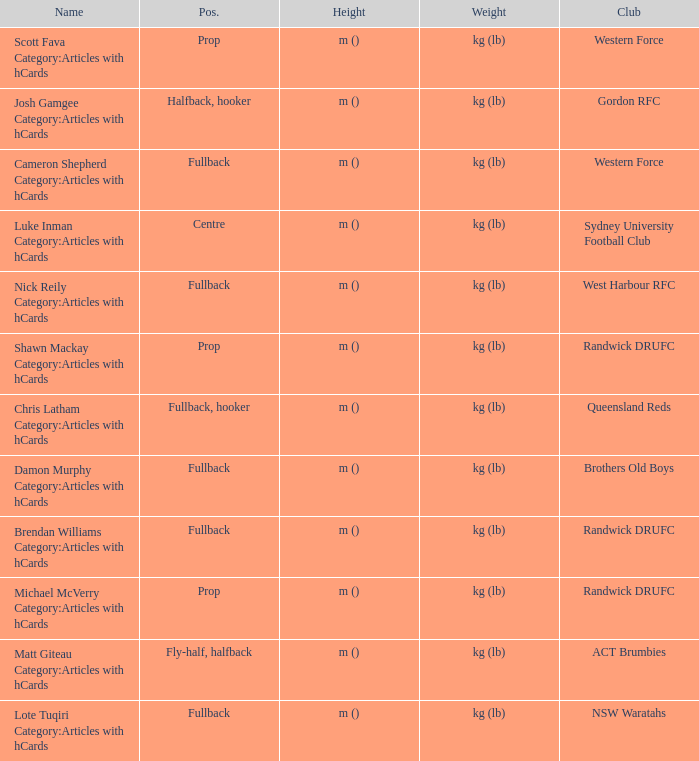What is the name when the position was fullback, hooker? Chris Latham Category:Articles with hCards. 